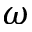<formula> <loc_0><loc_0><loc_500><loc_500>\omega</formula> 